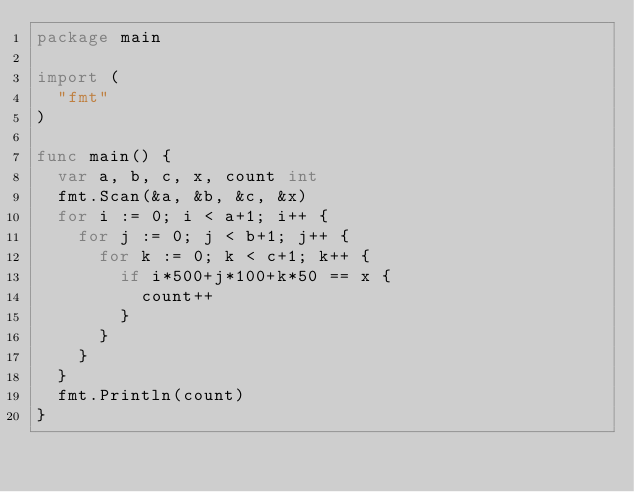Convert code to text. <code><loc_0><loc_0><loc_500><loc_500><_Go_>package main

import (
  "fmt"
)

func main() {
  var a, b, c, x, count int
  fmt.Scan(&a, &b, &c, &x)
  for i := 0; i < a+1; i++ {
    for j := 0; j < b+1; j++ {
      for k := 0; k < c+1; k++ {
        if i*500+j*100+k*50 == x {
          count++
        }
      }
    }
  }
  fmt.Println(count)
}
</code> 